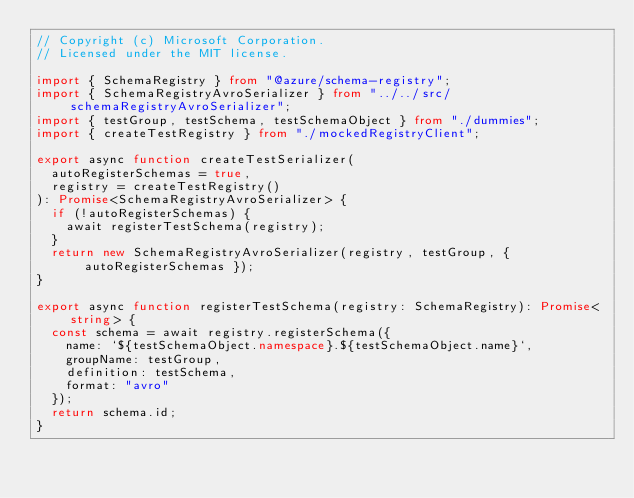Convert code to text. <code><loc_0><loc_0><loc_500><loc_500><_TypeScript_>// Copyright (c) Microsoft Corporation.
// Licensed under the MIT license.

import { SchemaRegistry } from "@azure/schema-registry";
import { SchemaRegistryAvroSerializer } from "../../src/schemaRegistryAvroSerializer";
import { testGroup, testSchema, testSchemaObject } from "./dummies";
import { createTestRegistry } from "./mockedRegistryClient";

export async function createTestSerializer(
  autoRegisterSchemas = true,
  registry = createTestRegistry()
): Promise<SchemaRegistryAvroSerializer> {
  if (!autoRegisterSchemas) {
    await registerTestSchema(registry);
  }
  return new SchemaRegistryAvroSerializer(registry, testGroup, { autoRegisterSchemas });
}

export async function registerTestSchema(registry: SchemaRegistry): Promise<string> {
  const schema = await registry.registerSchema({
    name: `${testSchemaObject.namespace}.${testSchemaObject.name}`,
    groupName: testGroup,
    definition: testSchema,
    format: "avro"
  });
  return schema.id;
}
</code> 